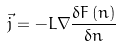<formula> <loc_0><loc_0><loc_500><loc_500>\vec { j } = - L \nabla \frac { \delta F \left ( n \right ) } { \delta n }</formula> 